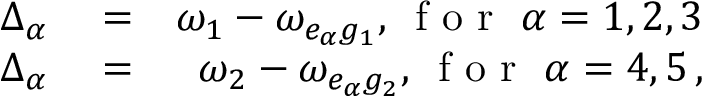Convert formula to latex. <formula><loc_0><loc_0><loc_500><loc_500>\begin{array} { r l r } { \Delta _ { \alpha } } & = } & { \omega _ { 1 } - \omega _ { e _ { \alpha } g _ { 1 } } , \, f o r \, \alpha = 1 , 2 , 3 } \\ { \Delta _ { \alpha } } & = } & { \omega _ { 2 } - \omega _ { e _ { \alpha } g _ { 2 } } , \, f o r \, \alpha = 4 , 5 \, , } \end{array}</formula> 